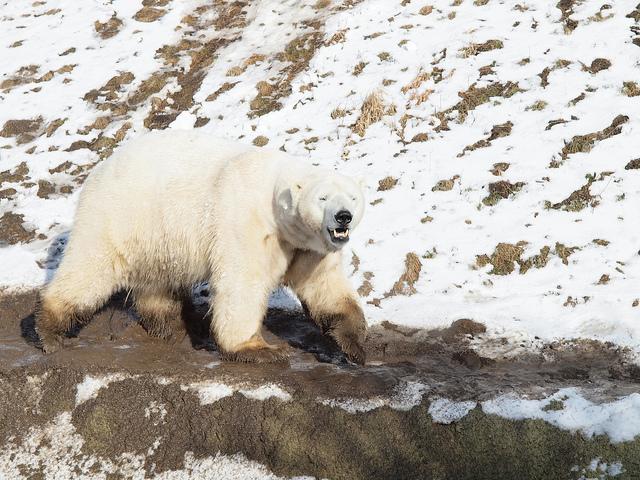Does the bear look towards the camera?
Keep it brief. Yes. What direction is the bear facing?
Concise answer only. Right. Is this a brown bear?
Answer briefly. No. Are the bear's feet dirty?
Give a very brief answer. Yes. Is the bear in the snow?
Answer briefly. No. What are the bears standing on?
Concise answer only. Dirt. 